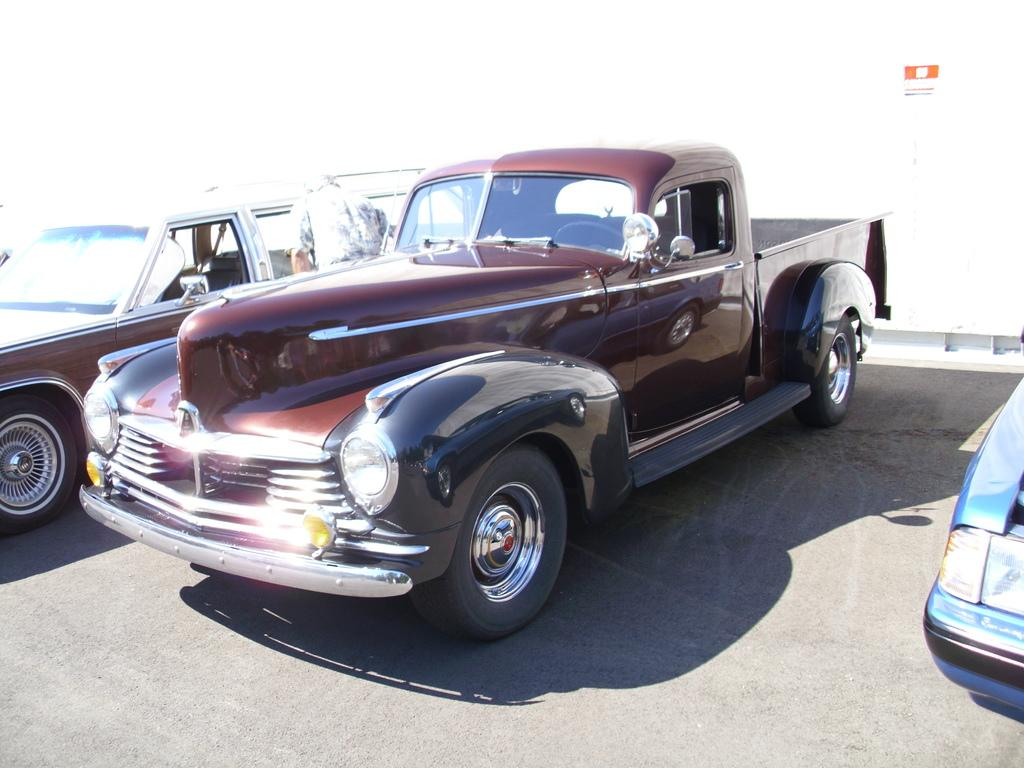What is the main subject of the image? The main subject of the image is cars on the road. Can you describe the location of the cars in the image? The cars are on the road in the center of the image. What type of brass instrument is the queen playing in the image? There is no queen or brass instrument present in the image; it features cars on the road. Does the existence of cars in the image prove the existence of life on other planets? The presence of cars in the image does not provide any information about the existence of life on other planets. 